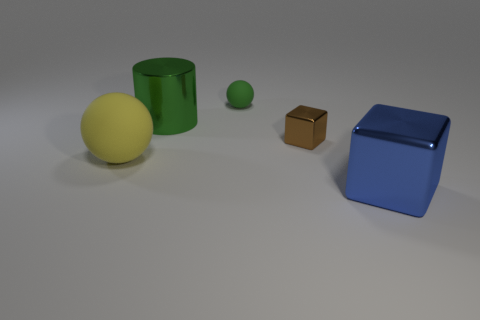If the yellow sphere was to roll towards one of the objects, which one would it hit first? If the yellow sphere were to roll straight ahead in the configuration shown in the image, it would first come into contact with the green cylinder, as it is the object closest to the sphere's current position.  Can you guess the weight comparison between these objects? Although I cannot measure the weight through the image alone, based on common materials and sizes, the blue plastic cube is likely the heaviest, followed by the yellow rubber sphere, the green rubber cylinder, and finally, the small brown cardboard cube is probably the lightest of them all. 